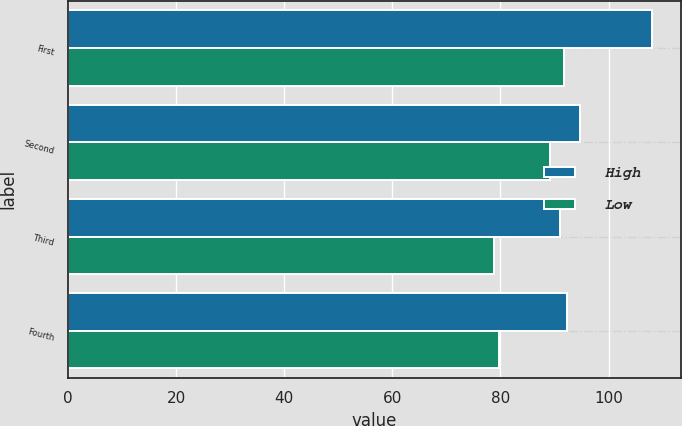Convert chart. <chart><loc_0><loc_0><loc_500><loc_500><stacked_bar_chart><ecel><fcel>First<fcel>Second<fcel>Third<fcel>Fourth<nl><fcel>High<fcel>108.07<fcel>94.74<fcel>91.02<fcel>92.32<nl><fcel>Low<fcel>91.74<fcel>89.17<fcel>78.76<fcel>79.77<nl></chart> 